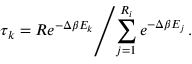<formula> <loc_0><loc_0><loc_500><loc_500>\tau _ { k } = R e ^ { - \Delta \beta E _ { k } } | d l e / \sum _ { j = 1 } ^ { R _ { i } } e ^ { - \Delta \beta E _ { j } } \, .</formula> 